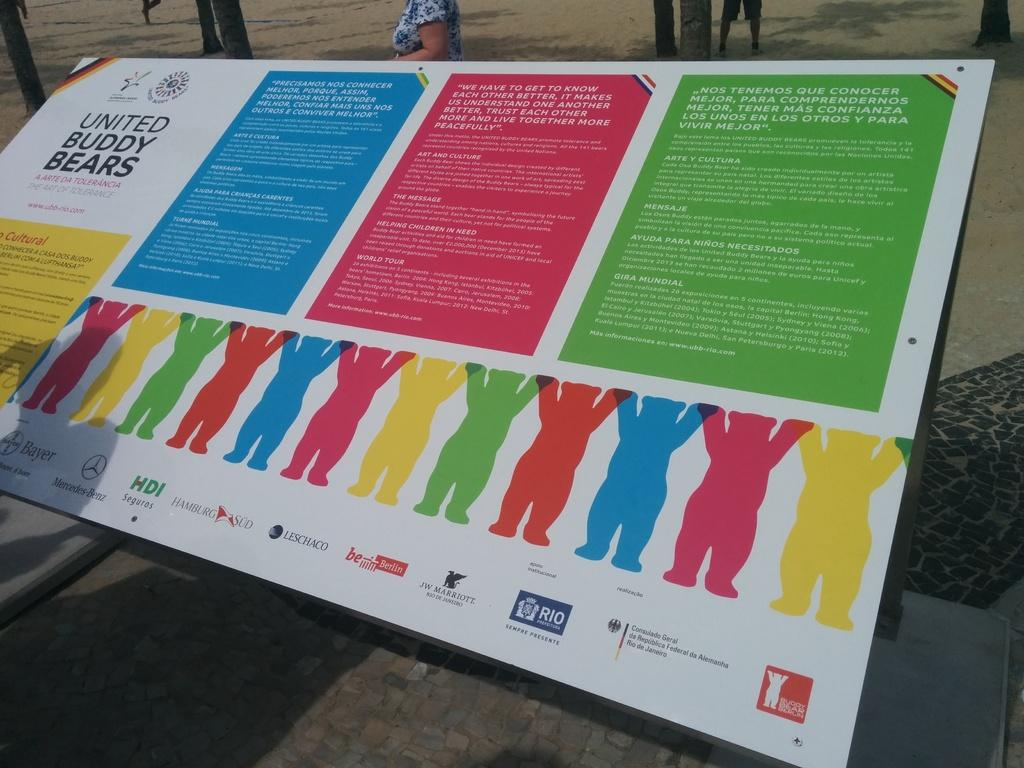<image>
Present a compact description of the photo's key features. A colorful signboard for the United Buddy Bears. 